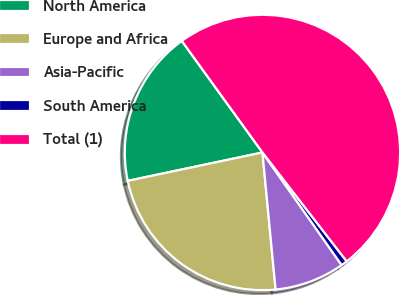Convert chart. <chart><loc_0><loc_0><loc_500><loc_500><pie_chart><fcel>North America<fcel>Europe and Africa<fcel>Asia-Pacific<fcel>South America<fcel>Total (1)<nl><fcel>18.34%<fcel>23.21%<fcel>8.23%<fcel>0.73%<fcel>49.48%<nl></chart> 